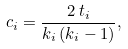Convert formula to latex. <formula><loc_0><loc_0><loc_500><loc_500>c _ { i } = \frac { 2 \, t _ { i } } { k _ { i } \, ( k _ { i } - 1 ) } ,</formula> 